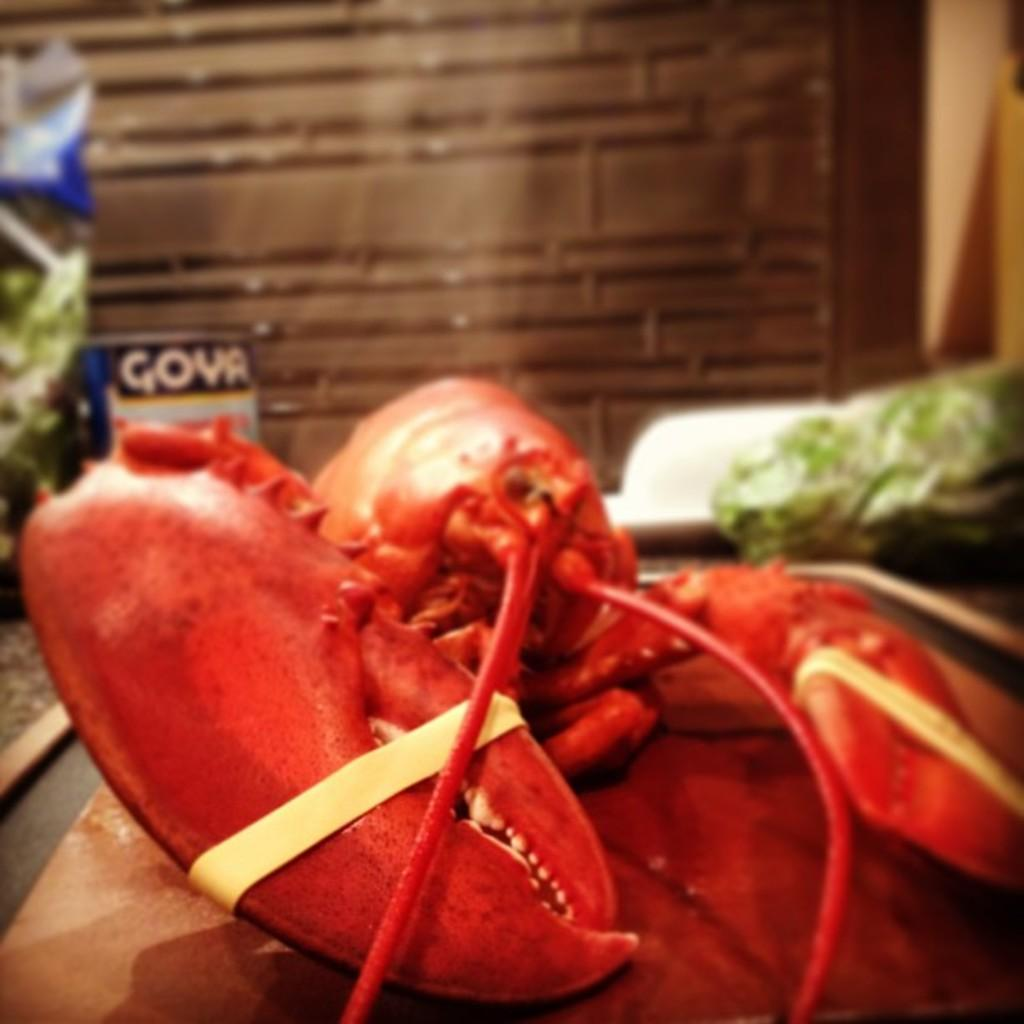What type of seafood can be seen in the image? There is an American lobster in the image. What is the lobster placed on? The lobster is placed on a board. Can you describe the background of the image? The background of the image is blurry. What else can be seen in the image besides the lobster? There are objects visible in the image. What type of structure is visible in the background? There is a wall in the background of the image. What type of attraction can be seen in the image? There is no attraction present in the image; it features an American lobster placed on a board. Is there a wheel visible in the image? There is no wheel present in the image. 